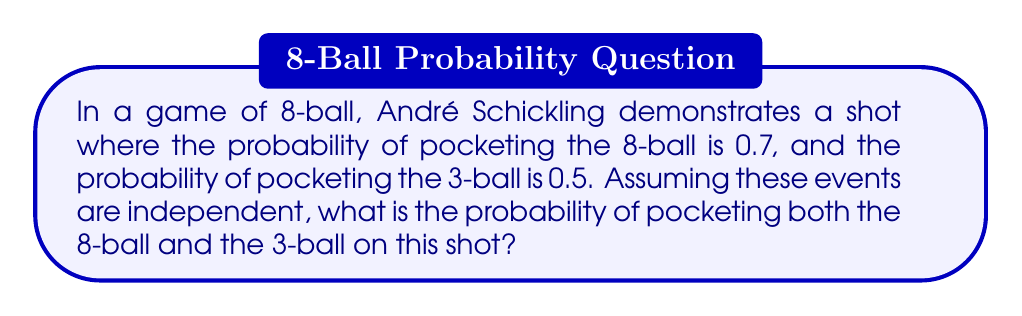Show me your answer to this math problem. Let's approach this step-by-step:

1) We are given:
   - P(pocketing 8-ball) = 0.7
   - P(pocketing 3-ball) = 0.5

2) We need to find the probability of both events occurring.

3) Since the events are independent (as stated in the question), we can use the multiplication rule of probability. This rule states that for independent events A and B:

   $$P(A \text{ and } B) = P(A) \times P(B)$$

4) In our case:
   - Event A: pocketing the 8-ball
   - Event B: pocketing the 3-ball

5) Applying the multiplication rule:

   $$P(\text{8-ball and 3-ball}) = P(\text{8-ball}) \times P(\text{3-ball})$$

6) Substituting the given probabilities:

   $$P(\text{8-ball and 3-ball}) = 0.7 \times 0.5$$

7) Calculating:

   $$P(\text{8-ball and 3-ball}) = 0.35$$

Thus, the probability of pocketing both the 8-ball and the 3-ball on this shot is 0.35 or 35%.
Answer: 0.35 